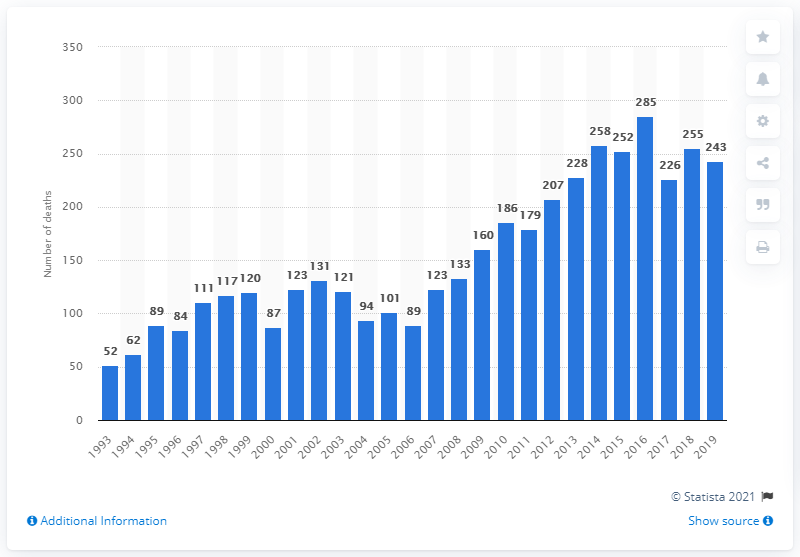Outline some significant characteristics in this image. In 2019, there were 243 reported deaths due to diazepam poisoning. 